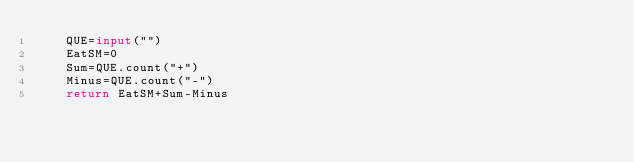<code> <loc_0><loc_0><loc_500><loc_500><_Python_>    QUE=input("")
    EatSM=0
    Sum=QUE.count("+")
    Minus=QUE.count("-")
    return EatSM+Sum-Minus</code> 